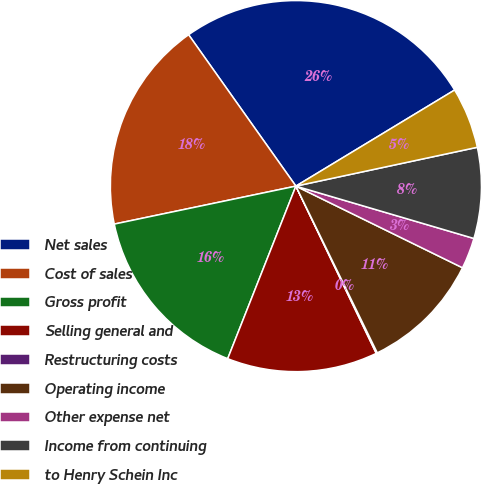<chart> <loc_0><loc_0><loc_500><loc_500><pie_chart><fcel>Net sales<fcel>Cost of sales<fcel>Gross profit<fcel>Selling general and<fcel>Restructuring costs<fcel>Operating income<fcel>Other expense net<fcel>Income from continuing<fcel>to Henry Schein Inc<nl><fcel>26.15%<fcel>18.47%<fcel>15.73%<fcel>13.12%<fcel>0.1%<fcel>10.52%<fcel>2.7%<fcel>7.91%<fcel>5.31%<nl></chart> 